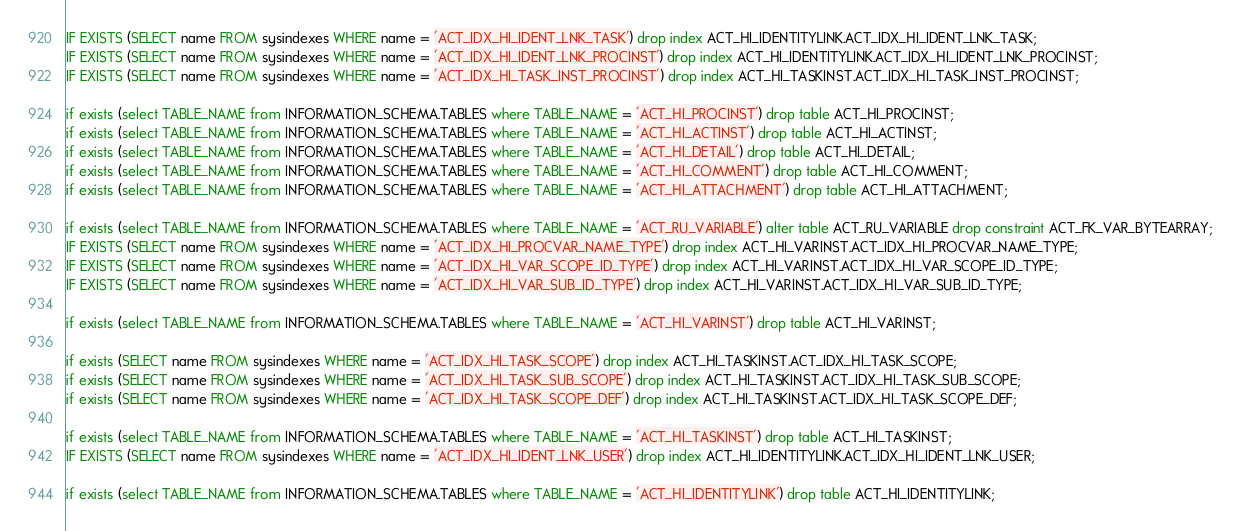Convert code to text. <code><loc_0><loc_0><loc_500><loc_500><_SQL_>IF EXISTS (SELECT name FROM sysindexes WHERE name = 'ACT_IDX_HI_IDENT_LNK_TASK') drop index ACT_HI_IDENTITYLINK.ACT_IDX_HI_IDENT_LNK_TASK;
IF EXISTS (SELECT name FROM sysindexes WHERE name = 'ACT_IDX_HI_IDENT_LNK_PROCINST') drop index ACT_HI_IDENTITYLINK.ACT_IDX_HI_IDENT_LNK_PROCINST;
IF EXISTS (SELECT name FROM sysindexes WHERE name = 'ACT_IDX_HI_TASK_INST_PROCINST') drop index ACT_HI_TASKINST.ACT_IDX_HI_TASK_INST_PROCINST;

if exists (select TABLE_NAME from INFORMATION_SCHEMA.TABLES where TABLE_NAME = 'ACT_HI_PROCINST') drop table ACT_HI_PROCINST;
if exists (select TABLE_NAME from INFORMATION_SCHEMA.TABLES where TABLE_NAME = 'ACT_HI_ACTINST') drop table ACT_HI_ACTINST;
if exists (select TABLE_NAME from INFORMATION_SCHEMA.TABLES where TABLE_NAME = 'ACT_HI_DETAIL') drop table ACT_HI_DETAIL;
if exists (select TABLE_NAME from INFORMATION_SCHEMA.TABLES where TABLE_NAME = 'ACT_HI_COMMENT') drop table ACT_HI_COMMENT;
if exists (select TABLE_NAME from INFORMATION_SCHEMA.TABLES where TABLE_NAME = 'ACT_HI_ATTACHMENT') drop table ACT_HI_ATTACHMENT;

if exists (select TABLE_NAME from INFORMATION_SCHEMA.TABLES where TABLE_NAME = 'ACT_RU_VARIABLE') alter table ACT_RU_VARIABLE drop constraint ACT_FK_VAR_BYTEARRAY;
IF EXISTS (SELECT name FROM sysindexes WHERE name = 'ACT_IDX_HI_PROCVAR_NAME_TYPE') drop index ACT_HI_VARINST.ACT_IDX_HI_PROCVAR_NAME_TYPE;
IF EXISTS (SELECT name FROM sysindexes WHERE name = 'ACT_IDX_HI_VAR_SCOPE_ID_TYPE') drop index ACT_HI_VARINST.ACT_IDX_HI_VAR_SCOPE_ID_TYPE;
IF EXISTS (SELECT name FROM sysindexes WHERE name = 'ACT_IDX_HI_VAR_SUB_ID_TYPE') drop index ACT_HI_VARINST.ACT_IDX_HI_VAR_SUB_ID_TYPE;

if exists (select TABLE_NAME from INFORMATION_SCHEMA.TABLES where TABLE_NAME = 'ACT_HI_VARINST') drop table ACT_HI_VARINST;

if exists (SELECT name FROM sysindexes WHERE name = 'ACT_IDX_HI_TASK_SCOPE') drop index ACT_HI_TASKINST.ACT_IDX_HI_TASK_SCOPE;
if exists (SELECT name FROM sysindexes WHERE name = 'ACT_IDX_HI_TASK_SUB_SCOPE') drop index ACT_HI_TASKINST.ACT_IDX_HI_TASK_SUB_SCOPE;
if exists (SELECT name FROM sysindexes WHERE name = 'ACT_IDX_HI_TASK_SCOPE_DEF') drop index ACT_HI_TASKINST.ACT_IDX_HI_TASK_SCOPE_DEF;

if exists (select TABLE_NAME from INFORMATION_SCHEMA.TABLES where TABLE_NAME = 'ACT_HI_TASKINST') drop table ACT_HI_TASKINST;
IF EXISTS (SELECT name FROM sysindexes WHERE name = 'ACT_IDX_HI_IDENT_LNK_USER') drop index ACT_HI_IDENTITYLINK.ACT_IDX_HI_IDENT_LNK_USER;

if exists (select TABLE_NAME from INFORMATION_SCHEMA.TABLES where TABLE_NAME = 'ACT_HI_IDENTITYLINK') drop table ACT_HI_IDENTITYLINK;
</code> 